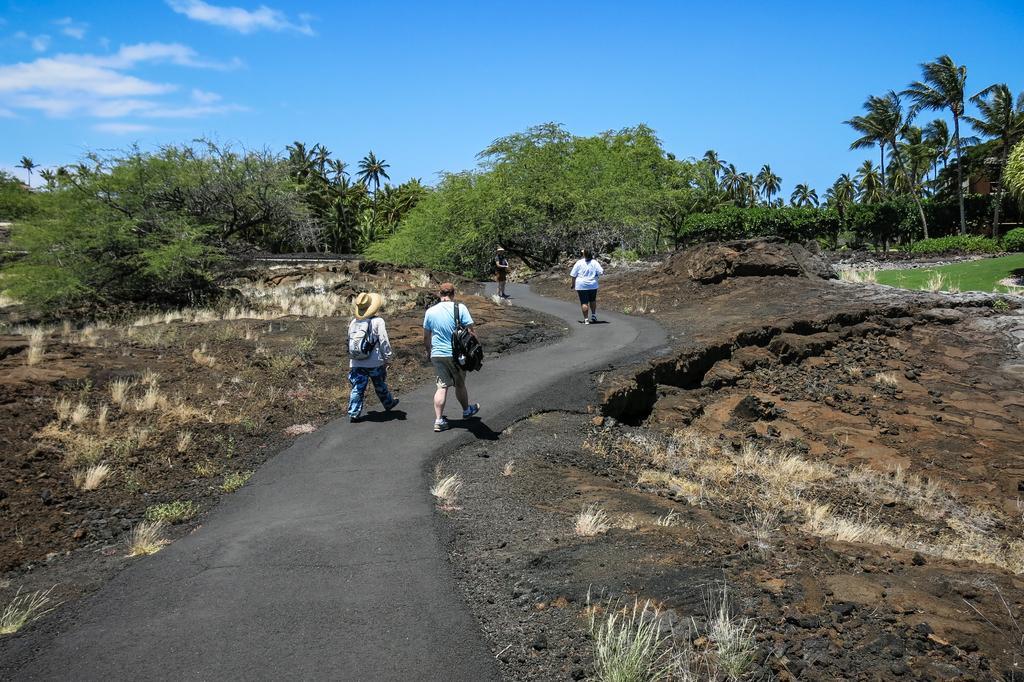In one or two sentences, can you explain what this image depicts? In this picture there are people in the image and there is muddy texture in the image and there are trees in the background area of the image. 